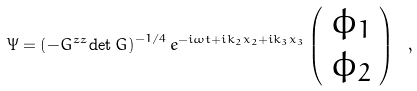<formula> <loc_0><loc_0><loc_500><loc_500>\Psi = \left ( - G ^ { z z } \det G \right ) ^ { - 1 / 4 } e ^ { - i \omega t + i k _ { 2 } x _ { 2 } + i k _ { 3 } x _ { 3 } } \left ( \begin{array} { c } \phi _ { 1 } \\ \phi _ { 2 } \end{array} \right ) \ ,</formula> 